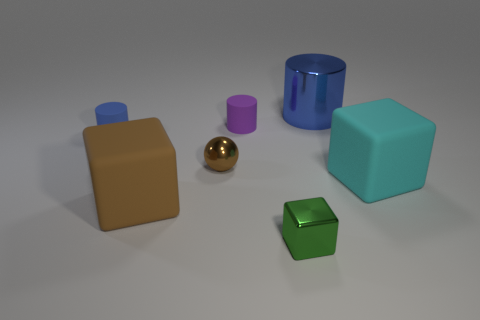Is the size of the brown shiny sphere the same as the blue cylinder that is on the left side of the tiny green shiny block?
Make the answer very short. Yes. How many other things are there of the same material as the green block?
Keep it short and to the point. 2. How many objects are either big objects right of the brown cube or blue things that are right of the small brown shiny sphere?
Offer a terse response. 2. What is the material of the purple thing that is the same shape as the blue shiny object?
Make the answer very short. Rubber. Is there a purple rubber object?
Your answer should be compact. Yes. How big is the metallic object that is both behind the small green cube and on the right side of the tiny brown shiny sphere?
Provide a succinct answer. Large. There is a small green object; what shape is it?
Ensure brevity in your answer.  Cube. There is a metal thing that is on the right side of the metal cube; is there a cylinder that is on the left side of it?
Your answer should be compact. Yes. What is the material of the blue thing that is the same size as the cyan matte block?
Your answer should be compact. Metal. Is there a brown rubber ball of the same size as the metal ball?
Offer a very short reply. No. 